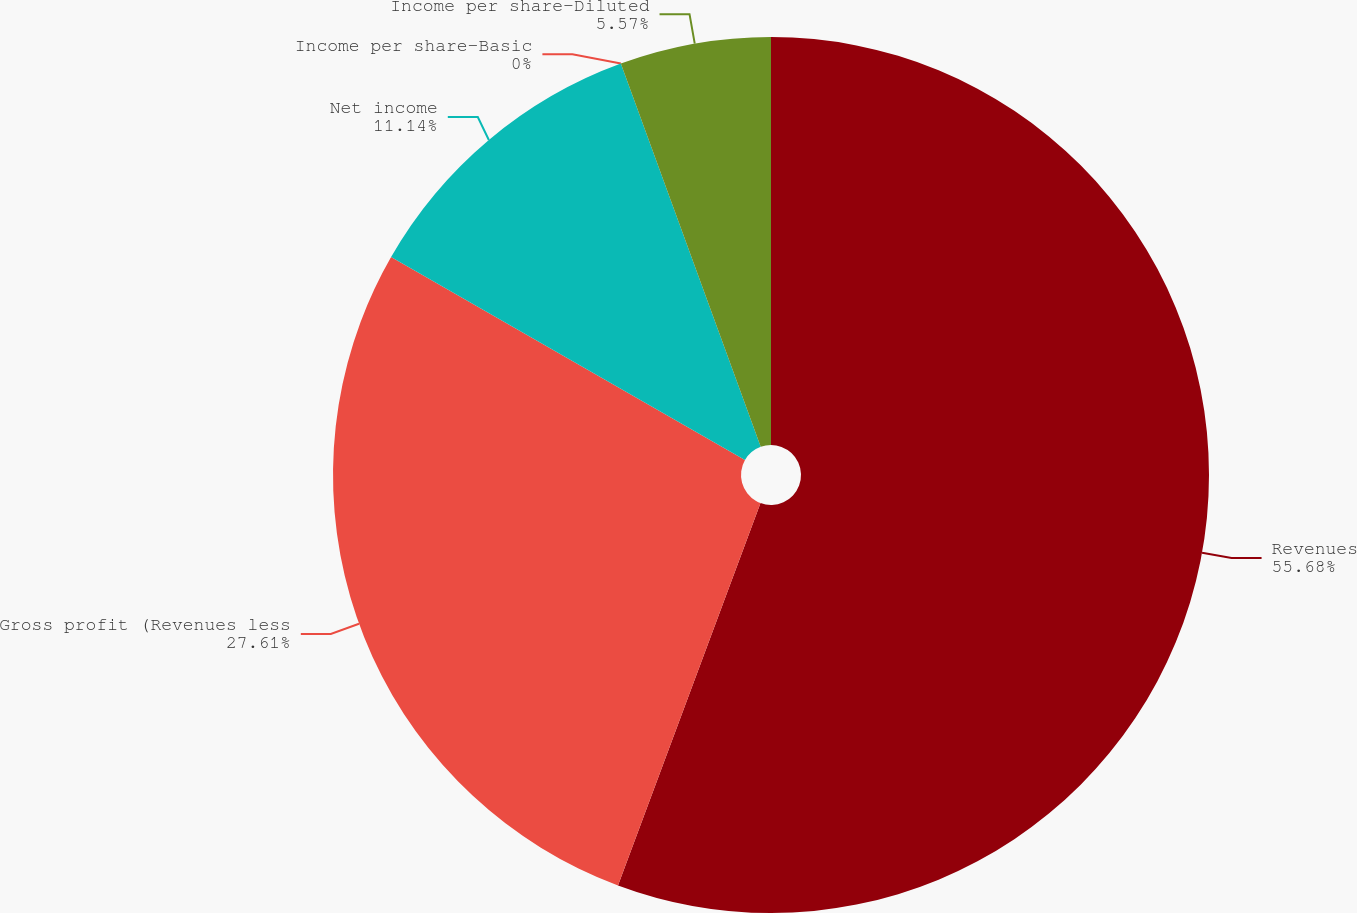Convert chart to OTSL. <chart><loc_0><loc_0><loc_500><loc_500><pie_chart><fcel>Revenues<fcel>Gross profit (Revenues less<fcel>Net income<fcel>Income per share-Basic<fcel>Income per share-Diluted<nl><fcel>55.68%<fcel>27.61%<fcel>11.14%<fcel>0.0%<fcel>5.57%<nl></chart> 